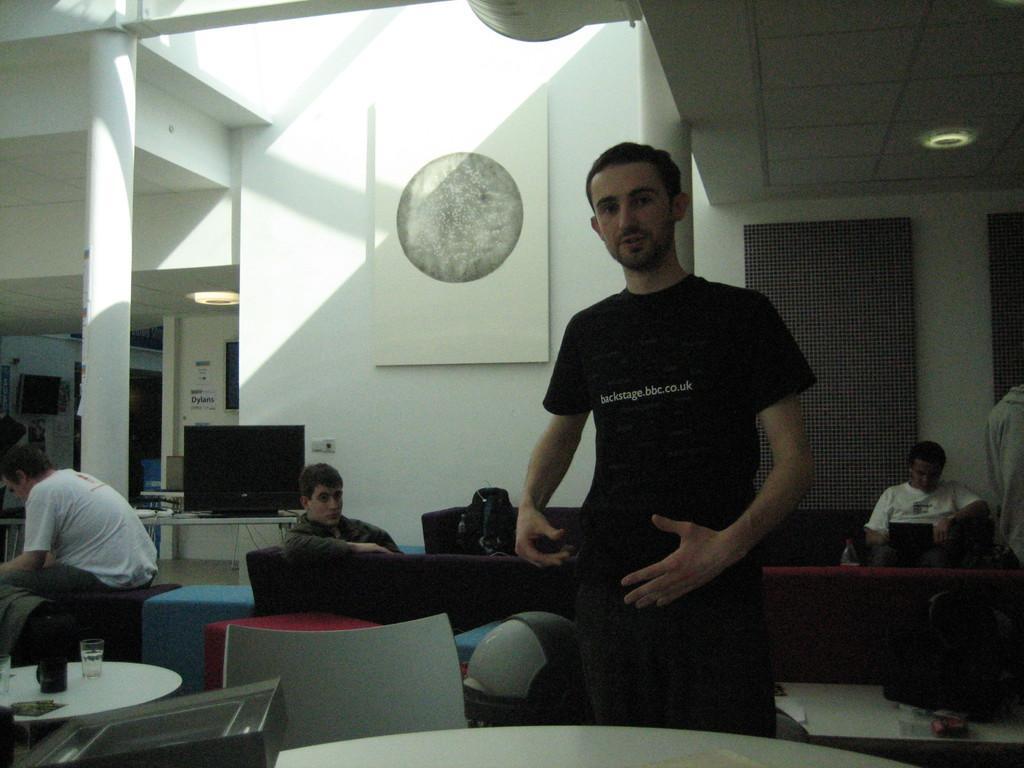Describe this image in one or two sentences. In this image i can see right side a person sit on the chair and wearing a white shirt and back side of him there is a wall,and left side a person sit in the chair wearing a white shirt. And back side of him there is a wall and TV monitor attached to the wall. And Just near to the person there is a table , on the table tv monitor. On the left corner there is a another table. on the table there are the teacups and water glass kept on the table. And in front there is a chair kept on the floor. and there is a sofa set on the sofa set a bag kept and on the sofa set a man sit wearing a gray color t- shirt. 